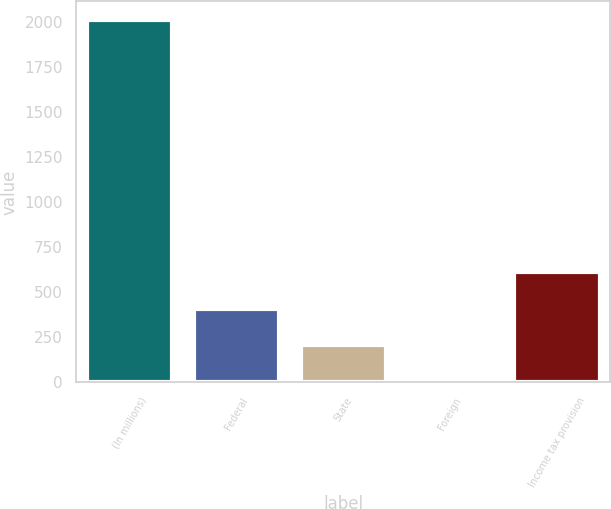<chart> <loc_0><loc_0><loc_500><loc_500><bar_chart><fcel>(In millions)<fcel>Federal<fcel>State<fcel>Foreign<fcel>Income tax provision<nl><fcel>2012<fcel>409.6<fcel>209.3<fcel>9<fcel>609.9<nl></chart> 